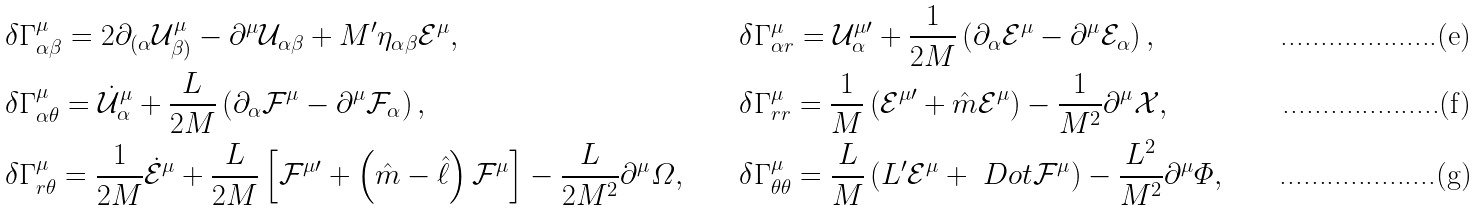Convert formula to latex. <formula><loc_0><loc_0><loc_500><loc_500>& \delta \Gamma ^ { \mu } _ { \alpha \beta } = 2 \partial _ { ( \alpha } \mathcal { U } _ { \beta ) } ^ { \mu } - \partial ^ { \mu } \mathcal { U } _ { \alpha \beta } + M ^ { \prime } \eta _ { \alpha \beta } \mathcal { E } ^ { \mu } , & & \delta \Gamma ^ { \mu } _ { \alpha r } = \mathcal { U } _ { \alpha } ^ { \mu \prime } + \frac { 1 } { 2 M } \left ( \partial _ { \alpha } \mathcal { E } ^ { \mu } - \partial ^ { \mu } \mathcal { E } _ { \alpha } \right ) , \\ & \delta \Gamma ^ { \mu } _ { \alpha \theta } = \dot { \mathcal { U } } _ { \alpha } ^ { \mu } + \frac { L } { 2 M } \left ( \partial _ { \alpha } \mathcal { F } ^ { \mu } - \partial ^ { \mu } \mathcal { F } _ { \alpha } \right ) , & & \delta \Gamma ^ { \mu } _ { r r } = \frac { 1 } { M } \left ( \mathcal { E } ^ { \mu \prime } + \hat { m } \mathcal { E } ^ { \mu } \right ) - \frac { 1 } { M ^ { 2 } } \partial ^ { \mu } \mathcal { X } , \\ & \delta \Gamma ^ { \mu } _ { r \theta } = \frac { 1 } { 2 M } \dot { \mathcal { E } } ^ { \mu } + \frac { L } { 2 M } \left [ \mathcal { F } ^ { \mu \prime } + \left ( \hat { m } - \hat { \ell } \right ) \mathcal { F } ^ { \mu } \right ] - \frac { L } { 2 M ^ { 2 } } \partial ^ { \mu } \varOmega , & & \delta \Gamma ^ { \mu } _ { \theta \theta } = \frac { L } { M } \left ( L ^ { \prime } \mathcal { E } ^ { \mu } + \ D o t { \mathcal { F } } ^ { \mu } \right ) - \frac { L ^ { 2 } } { M ^ { 2 } } \partial ^ { \mu } \varPhi ,</formula> 